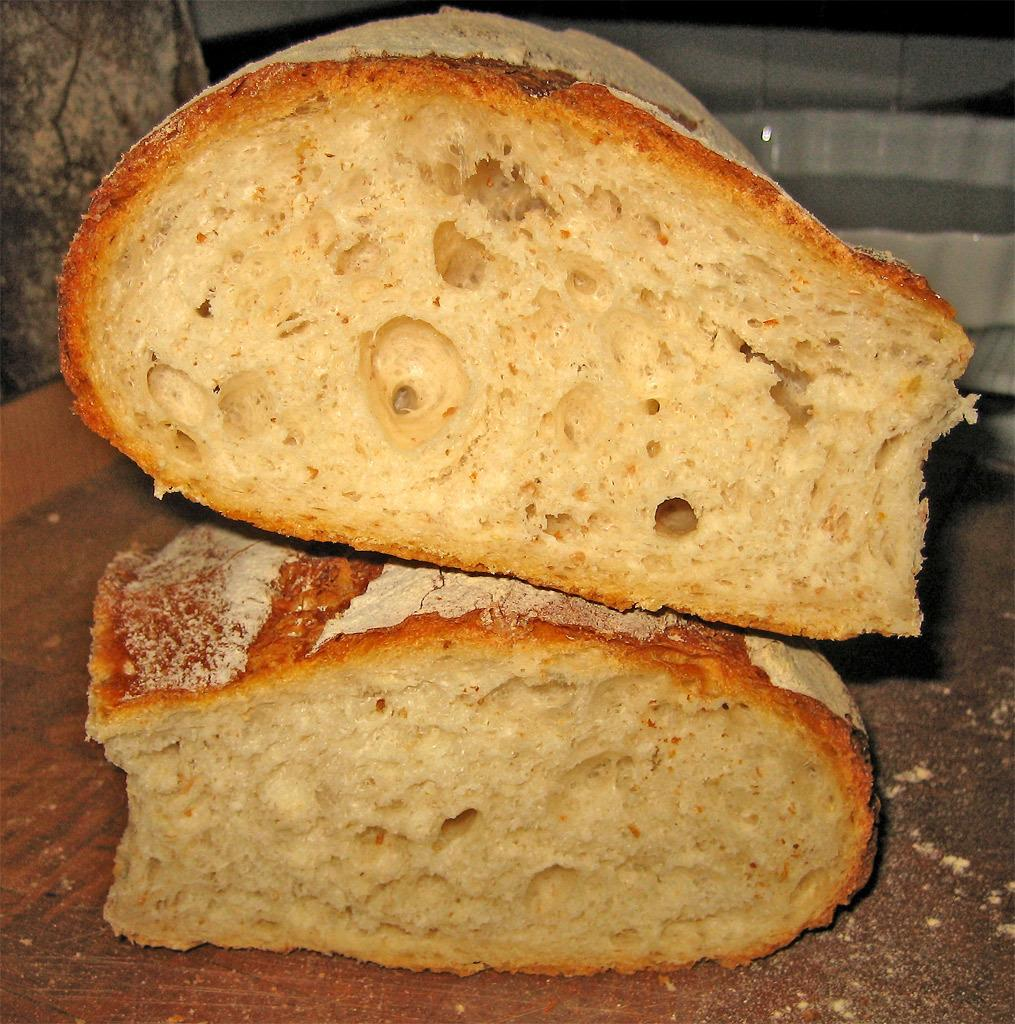What is the main object in the image? There is a wooden plank in the image. What food item can be seen in the image? There are two bun slices stacked on top of each other in the image. Can you describe any other objects in the background of the image? There is a white color bowl in the background of the image. How many donkeys are carrying the wooden plank in the image? There are no donkeys present in the image, and the wooden plank is not being carried by any animals. 